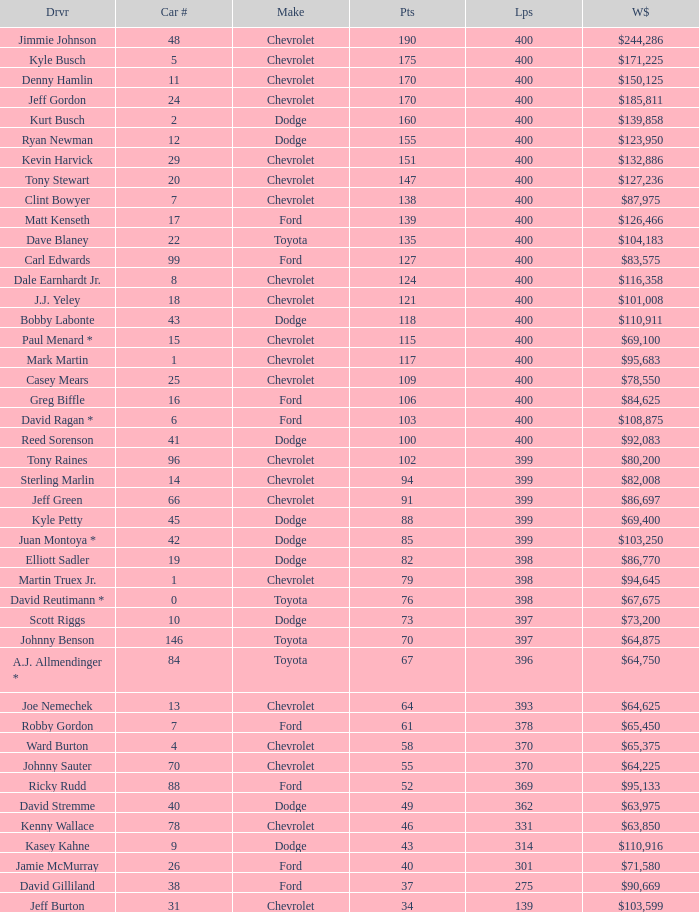What brand is car number 31? Chevrolet. Can you parse all the data within this table? {'header': ['Drvr', 'Car #', 'Make', 'Pts', 'Lps', 'W$'], 'rows': [['Jimmie Johnson', '48', 'Chevrolet', '190', '400', '$244,286'], ['Kyle Busch', '5', 'Chevrolet', '175', '400', '$171,225'], ['Denny Hamlin', '11', 'Chevrolet', '170', '400', '$150,125'], ['Jeff Gordon', '24', 'Chevrolet', '170', '400', '$185,811'], ['Kurt Busch', '2', 'Dodge', '160', '400', '$139,858'], ['Ryan Newman', '12', 'Dodge', '155', '400', '$123,950'], ['Kevin Harvick', '29', 'Chevrolet', '151', '400', '$132,886'], ['Tony Stewart', '20', 'Chevrolet', '147', '400', '$127,236'], ['Clint Bowyer', '7', 'Chevrolet', '138', '400', '$87,975'], ['Matt Kenseth', '17', 'Ford', '139', '400', '$126,466'], ['Dave Blaney', '22', 'Toyota', '135', '400', '$104,183'], ['Carl Edwards', '99', 'Ford', '127', '400', '$83,575'], ['Dale Earnhardt Jr.', '8', 'Chevrolet', '124', '400', '$116,358'], ['J.J. Yeley', '18', 'Chevrolet', '121', '400', '$101,008'], ['Bobby Labonte', '43', 'Dodge', '118', '400', '$110,911'], ['Paul Menard *', '15', 'Chevrolet', '115', '400', '$69,100'], ['Mark Martin', '1', 'Chevrolet', '117', '400', '$95,683'], ['Casey Mears', '25', 'Chevrolet', '109', '400', '$78,550'], ['Greg Biffle', '16', 'Ford', '106', '400', '$84,625'], ['David Ragan *', '6', 'Ford', '103', '400', '$108,875'], ['Reed Sorenson', '41', 'Dodge', '100', '400', '$92,083'], ['Tony Raines', '96', 'Chevrolet', '102', '399', '$80,200'], ['Sterling Marlin', '14', 'Chevrolet', '94', '399', '$82,008'], ['Jeff Green', '66', 'Chevrolet', '91', '399', '$86,697'], ['Kyle Petty', '45', 'Dodge', '88', '399', '$69,400'], ['Juan Montoya *', '42', 'Dodge', '85', '399', '$103,250'], ['Elliott Sadler', '19', 'Dodge', '82', '398', '$86,770'], ['Martin Truex Jr.', '1', 'Chevrolet', '79', '398', '$94,645'], ['David Reutimann *', '0', 'Toyota', '76', '398', '$67,675'], ['Scott Riggs', '10', 'Dodge', '73', '397', '$73,200'], ['Johnny Benson', '146', 'Toyota', '70', '397', '$64,875'], ['A.J. Allmendinger *', '84', 'Toyota', '67', '396', '$64,750'], ['Joe Nemechek', '13', 'Chevrolet', '64', '393', '$64,625'], ['Robby Gordon', '7', 'Ford', '61', '378', '$65,450'], ['Ward Burton', '4', 'Chevrolet', '58', '370', '$65,375'], ['Johnny Sauter', '70', 'Chevrolet', '55', '370', '$64,225'], ['Ricky Rudd', '88', 'Ford', '52', '369', '$95,133'], ['David Stremme', '40', 'Dodge', '49', '362', '$63,975'], ['Kenny Wallace', '78', 'Chevrolet', '46', '331', '$63,850'], ['Kasey Kahne', '9', 'Dodge', '43', '314', '$110,916'], ['Jamie McMurray', '26', 'Ford', '40', '301', '$71,580'], ['David Gilliland', '38', 'Ford', '37', '275', '$90,669'], ['Jeff Burton', '31', 'Chevrolet', '34', '139', '$103,599']]} 